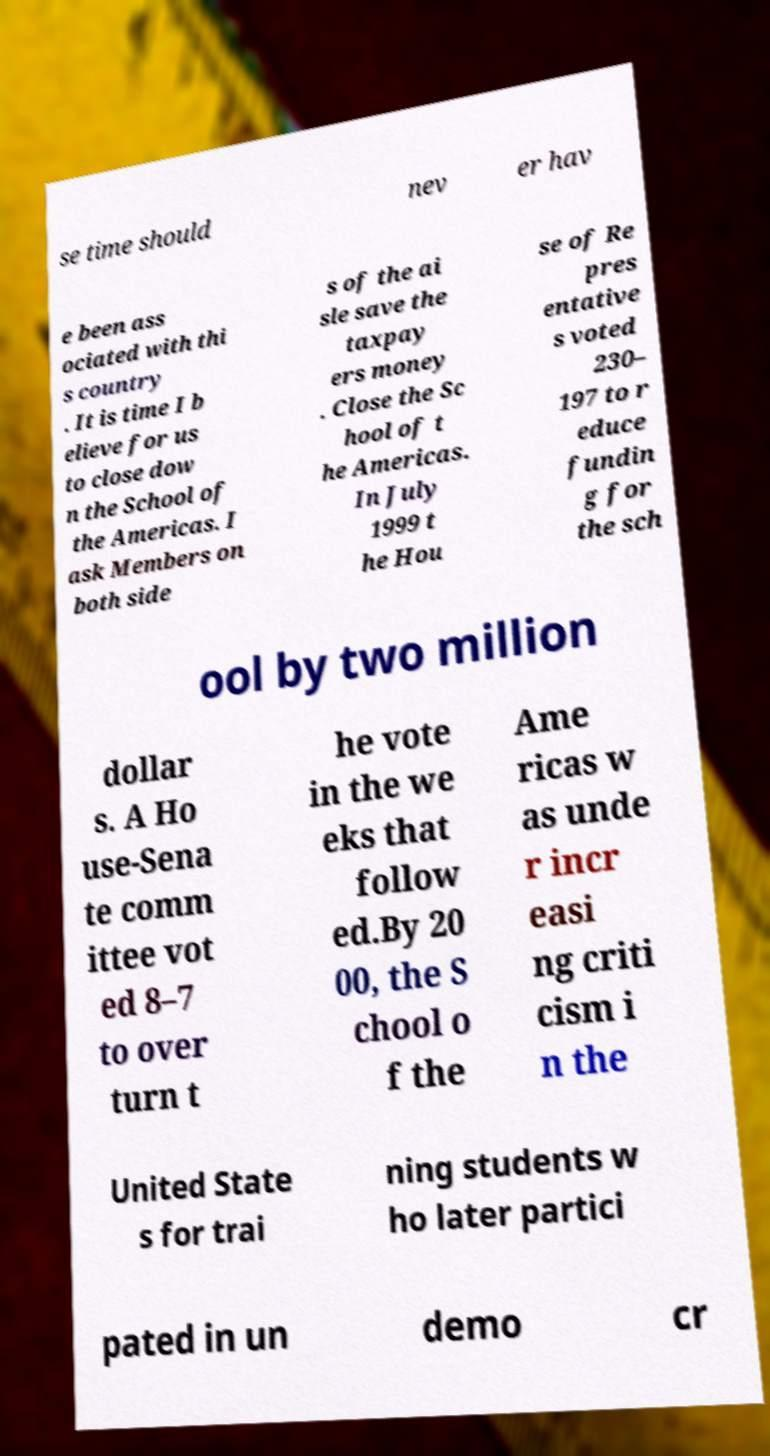Please read and relay the text visible in this image. What does it say? se time should nev er hav e been ass ociated with thi s country . It is time I b elieve for us to close dow n the School of the Americas. I ask Members on both side s of the ai sle save the taxpay ers money . Close the Sc hool of t he Americas. In July 1999 t he Hou se of Re pres entative s voted 230– 197 to r educe fundin g for the sch ool by two million dollar s. A Ho use-Sena te comm ittee vot ed 8–7 to over turn t he vote in the we eks that follow ed.By 20 00, the S chool o f the Ame ricas w as unde r incr easi ng criti cism i n the United State s for trai ning students w ho later partici pated in un demo cr 